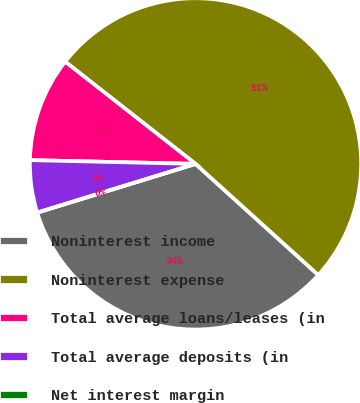Convert chart to OTSL. <chart><loc_0><loc_0><loc_500><loc_500><pie_chart><fcel>Noninterest income<fcel>Noninterest expense<fcel>Total average loans/leases (in<fcel>Total average deposits (in<fcel>Net interest margin<nl><fcel>33.54%<fcel>51.12%<fcel>10.22%<fcel>5.11%<fcel>0.0%<nl></chart> 